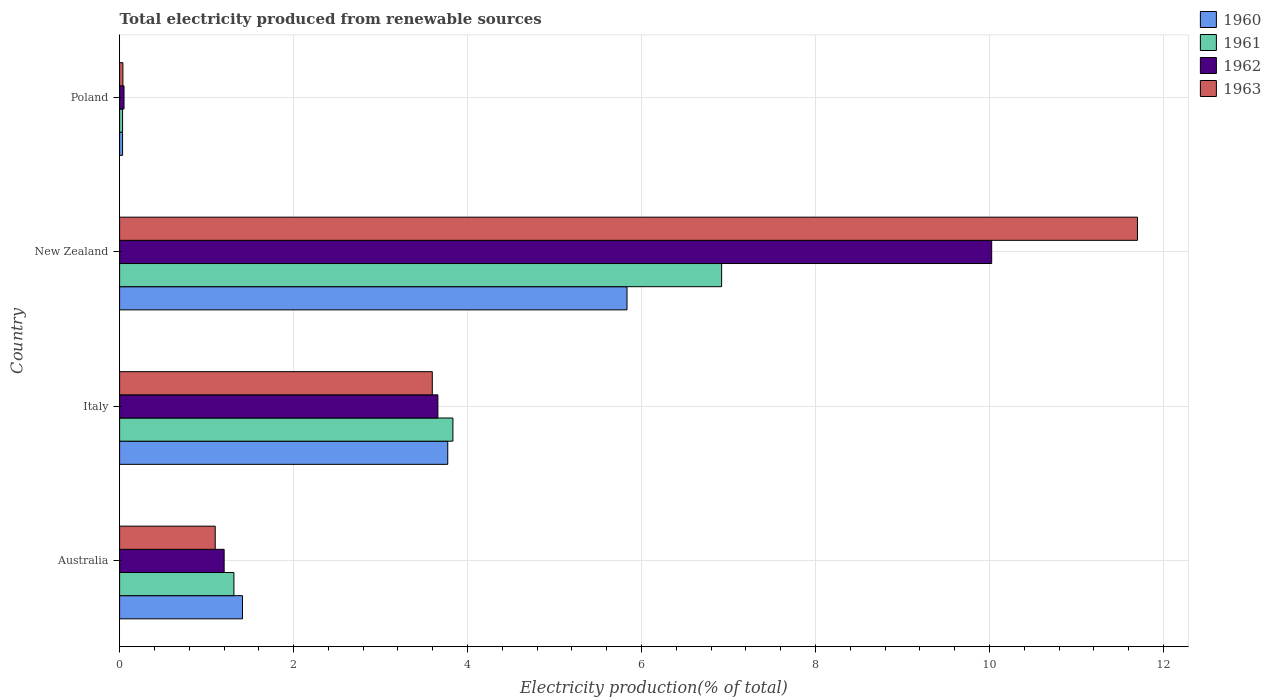How many different coloured bars are there?
Make the answer very short. 4. Are the number of bars on each tick of the Y-axis equal?
Provide a succinct answer. Yes. How many bars are there on the 1st tick from the top?
Your answer should be compact. 4. What is the label of the 2nd group of bars from the top?
Offer a very short reply. New Zealand. What is the total electricity produced in 1963 in Poland?
Make the answer very short. 0.04. Across all countries, what is the maximum total electricity produced in 1960?
Provide a short and direct response. 5.83. Across all countries, what is the minimum total electricity produced in 1963?
Make the answer very short. 0.04. In which country was the total electricity produced in 1963 maximum?
Offer a terse response. New Zealand. What is the total total electricity produced in 1963 in the graph?
Your answer should be compact. 16.43. What is the difference between the total electricity produced in 1963 in Italy and that in New Zealand?
Offer a terse response. -8.11. What is the difference between the total electricity produced in 1963 in Australia and the total electricity produced in 1961 in Italy?
Your response must be concise. -2.73. What is the average total electricity produced in 1963 per country?
Provide a succinct answer. 4.11. What is the difference between the total electricity produced in 1961 and total electricity produced in 1963 in Australia?
Give a very brief answer. 0.21. What is the ratio of the total electricity produced in 1963 in Italy to that in Poland?
Keep it short and to the point. 94.84. What is the difference between the highest and the second highest total electricity produced in 1960?
Provide a short and direct response. 2.06. What is the difference between the highest and the lowest total electricity produced in 1961?
Provide a short and direct response. 6.89. In how many countries, is the total electricity produced in 1961 greater than the average total electricity produced in 1961 taken over all countries?
Ensure brevity in your answer.  2. Is the sum of the total electricity produced in 1963 in Australia and New Zealand greater than the maximum total electricity produced in 1960 across all countries?
Keep it short and to the point. Yes. What does the 4th bar from the top in Australia represents?
Your answer should be very brief. 1960. What does the 1st bar from the bottom in Australia represents?
Ensure brevity in your answer.  1960. Is it the case that in every country, the sum of the total electricity produced in 1960 and total electricity produced in 1963 is greater than the total electricity produced in 1961?
Your answer should be compact. Yes. Are all the bars in the graph horizontal?
Your response must be concise. Yes. Does the graph contain grids?
Offer a terse response. Yes. Where does the legend appear in the graph?
Your response must be concise. Top right. How are the legend labels stacked?
Your answer should be very brief. Vertical. What is the title of the graph?
Keep it short and to the point. Total electricity produced from renewable sources. What is the label or title of the X-axis?
Offer a very short reply. Electricity production(% of total). What is the Electricity production(% of total) in 1960 in Australia?
Ensure brevity in your answer.  1.41. What is the Electricity production(% of total) in 1961 in Australia?
Offer a very short reply. 1.31. What is the Electricity production(% of total) of 1962 in Australia?
Your answer should be very brief. 1.2. What is the Electricity production(% of total) of 1963 in Australia?
Offer a very short reply. 1.1. What is the Electricity production(% of total) in 1960 in Italy?
Provide a short and direct response. 3.77. What is the Electricity production(% of total) in 1961 in Italy?
Ensure brevity in your answer.  3.83. What is the Electricity production(% of total) in 1962 in Italy?
Your answer should be very brief. 3.66. What is the Electricity production(% of total) in 1963 in Italy?
Keep it short and to the point. 3.59. What is the Electricity production(% of total) of 1960 in New Zealand?
Offer a terse response. 5.83. What is the Electricity production(% of total) in 1961 in New Zealand?
Provide a succinct answer. 6.92. What is the Electricity production(% of total) in 1962 in New Zealand?
Your response must be concise. 10.02. What is the Electricity production(% of total) of 1963 in New Zealand?
Provide a succinct answer. 11.7. What is the Electricity production(% of total) of 1960 in Poland?
Keep it short and to the point. 0.03. What is the Electricity production(% of total) in 1961 in Poland?
Your response must be concise. 0.03. What is the Electricity production(% of total) in 1962 in Poland?
Your answer should be compact. 0.05. What is the Electricity production(% of total) in 1963 in Poland?
Your answer should be very brief. 0.04. Across all countries, what is the maximum Electricity production(% of total) of 1960?
Your answer should be compact. 5.83. Across all countries, what is the maximum Electricity production(% of total) of 1961?
Make the answer very short. 6.92. Across all countries, what is the maximum Electricity production(% of total) of 1962?
Keep it short and to the point. 10.02. Across all countries, what is the maximum Electricity production(% of total) of 1963?
Provide a succinct answer. 11.7. Across all countries, what is the minimum Electricity production(% of total) in 1960?
Your answer should be compact. 0.03. Across all countries, what is the minimum Electricity production(% of total) of 1961?
Provide a short and direct response. 0.03. Across all countries, what is the minimum Electricity production(% of total) of 1962?
Your response must be concise. 0.05. Across all countries, what is the minimum Electricity production(% of total) of 1963?
Offer a very short reply. 0.04. What is the total Electricity production(% of total) of 1960 in the graph?
Ensure brevity in your answer.  11.05. What is the total Electricity production(% of total) in 1962 in the graph?
Provide a succinct answer. 14.94. What is the total Electricity production(% of total) in 1963 in the graph?
Your response must be concise. 16.43. What is the difference between the Electricity production(% of total) in 1960 in Australia and that in Italy?
Keep it short and to the point. -2.36. What is the difference between the Electricity production(% of total) in 1961 in Australia and that in Italy?
Your answer should be very brief. -2.52. What is the difference between the Electricity production(% of total) of 1962 in Australia and that in Italy?
Keep it short and to the point. -2.46. What is the difference between the Electricity production(% of total) in 1963 in Australia and that in Italy?
Offer a terse response. -2.5. What is the difference between the Electricity production(% of total) of 1960 in Australia and that in New Zealand?
Offer a very short reply. -4.42. What is the difference between the Electricity production(% of total) in 1961 in Australia and that in New Zealand?
Provide a short and direct response. -5.61. What is the difference between the Electricity production(% of total) of 1962 in Australia and that in New Zealand?
Give a very brief answer. -8.82. What is the difference between the Electricity production(% of total) in 1963 in Australia and that in New Zealand?
Your response must be concise. -10.6. What is the difference between the Electricity production(% of total) of 1960 in Australia and that in Poland?
Ensure brevity in your answer.  1.38. What is the difference between the Electricity production(% of total) of 1961 in Australia and that in Poland?
Provide a short and direct response. 1.28. What is the difference between the Electricity production(% of total) in 1962 in Australia and that in Poland?
Keep it short and to the point. 1.15. What is the difference between the Electricity production(% of total) of 1963 in Australia and that in Poland?
Provide a short and direct response. 1.06. What is the difference between the Electricity production(% of total) of 1960 in Italy and that in New Zealand?
Make the answer very short. -2.06. What is the difference between the Electricity production(% of total) of 1961 in Italy and that in New Zealand?
Offer a terse response. -3.09. What is the difference between the Electricity production(% of total) in 1962 in Italy and that in New Zealand?
Your response must be concise. -6.37. What is the difference between the Electricity production(% of total) of 1963 in Italy and that in New Zealand?
Give a very brief answer. -8.11. What is the difference between the Electricity production(% of total) of 1960 in Italy and that in Poland?
Make the answer very short. 3.74. What is the difference between the Electricity production(% of total) of 1961 in Italy and that in Poland?
Provide a succinct answer. 3.8. What is the difference between the Electricity production(% of total) of 1962 in Italy and that in Poland?
Your answer should be very brief. 3.61. What is the difference between the Electricity production(% of total) in 1963 in Italy and that in Poland?
Your answer should be very brief. 3.56. What is the difference between the Electricity production(% of total) of 1960 in New Zealand and that in Poland?
Keep it short and to the point. 5.8. What is the difference between the Electricity production(% of total) of 1961 in New Zealand and that in Poland?
Make the answer very short. 6.89. What is the difference between the Electricity production(% of total) in 1962 in New Zealand and that in Poland?
Your response must be concise. 9.97. What is the difference between the Electricity production(% of total) of 1963 in New Zealand and that in Poland?
Your response must be concise. 11.66. What is the difference between the Electricity production(% of total) in 1960 in Australia and the Electricity production(% of total) in 1961 in Italy?
Offer a very short reply. -2.42. What is the difference between the Electricity production(% of total) in 1960 in Australia and the Electricity production(% of total) in 1962 in Italy?
Your response must be concise. -2.25. What is the difference between the Electricity production(% of total) of 1960 in Australia and the Electricity production(% of total) of 1963 in Italy?
Provide a short and direct response. -2.18. What is the difference between the Electricity production(% of total) of 1961 in Australia and the Electricity production(% of total) of 1962 in Italy?
Your response must be concise. -2.34. What is the difference between the Electricity production(% of total) in 1961 in Australia and the Electricity production(% of total) in 1963 in Italy?
Your response must be concise. -2.28. What is the difference between the Electricity production(% of total) of 1962 in Australia and the Electricity production(% of total) of 1963 in Italy?
Make the answer very short. -2.39. What is the difference between the Electricity production(% of total) of 1960 in Australia and the Electricity production(% of total) of 1961 in New Zealand?
Give a very brief answer. -5.51. What is the difference between the Electricity production(% of total) in 1960 in Australia and the Electricity production(% of total) in 1962 in New Zealand?
Offer a very short reply. -8.61. What is the difference between the Electricity production(% of total) in 1960 in Australia and the Electricity production(% of total) in 1963 in New Zealand?
Provide a short and direct response. -10.29. What is the difference between the Electricity production(% of total) in 1961 in Australia and the Electricity production(% of total) in 1962 in New Zealand?
Your response must be concise. -8.71. What is the difference between the Electricity production(% of total) in 1961 in Australia and the Electricity production(% of total) in 1963 in New Zealand?
Ensure brevity in your answer.  -10.39. What is the difference between the Electricity production(% of total) in 1962 in Australia and the Electricity production(% of total) in 1963 in New Zealand?
Your response must be concise. -10.5. What is the difference between the Electricity production(% of total) of 1960 in Australia and the Electricity production(% of total) of 1961 in Poland?
Offer a terse response. 1.38. What is the difference between the Electricity production(% of total) in 1960 in Australia and the Electricity production(% of total) in 1962 in Poland?
Provide a succinct answer. 1.36. What is the difference between the Electricity production(% of total) of 1960 in Australia and the Electricity production(% of total) of 1963 in Poland?
Provide a short and direct response. 1.37. What is the difference between the Electricity production(% of total) of 1961 in Australia and the Electricity production(% of total) of 1962 in Poland?
Give a very brief answer. 1.26. What is the difference between the Electricity production(% of total) in 1961 in Australia and the Electricity production(% of total) in 1963 in Poland?
Offer a very short reply. 1.28. What is the difference between the Electricity production(% of total) of 1962 in Australia and the Electricity production(% of total) of 1963 in Poland?
Your answer should be compact. 1.16. What is the difference between the Electricity production(% of total) of 1960 in Italy and the Electricity production(% of total) of 1961 in New Zealand?
Ensure brevity in your answer.  -3.15. What is the difference between the Electricity production(% of total) in 1960 in Italy and the Electricity production(% of total) in 1962 in New Zealand?
Offer a terse response. -6.25. What is the difference between the Electricity production(% of total) of 1960 in Italy and the Electricity production(% of total) of 1963 in New Zealand?
Provide a succinct answer. -7.93. What is the difference between the Electricity production(% of total) in 1961 in Italy and the Electricity production(% of total) in 1962 in New Zealand?
Offer a terse response. -6.19. What is the difference between the Electricity production(% of total) in 1961 in Italy and the Electricity production(% of total) in 1963 in New Zealand?
Offer a very short reply. -7.87. What is the difference between the Electricity production(% of total) in 1962 in Italy and the Electricity production(% of total) in 1963 in New Zealand?
Give a very brief answer. -8.04. What is the difference between the Electricity production(% of total) in 1960 in Italy and the Electricity production(% of total) in 1961 in Poland?
Provide a short and direct response. 3.74. What is the difference between the Electricity production(% of total) of 1960 in Italy and the Electricity production(% of total) of 1962 in Poland?
Offer a terse response. 3.72. What is the difference between the Electricity production(% of total) in 1960 in Italy and the Electricity production(% of total) in 1963 in Poland?
Give a very brief answer. 3.73. What is the difference between the Electricity production(% of total) in 1961 in Italy and the Electricity production(% of total) in 1962 in Poland?
Give a very brief answer. 3.78. What is the difference between the Electricity production(% of total) in 1961 in Italy and the Electricity production(% of total) in 1963 in Poland?
Give a very brief answer. 3.79. What is the difference between the Electricity production(% of total) in 1962 in Italy and the Electricity production(% of total) in 1963 in Poland?
Your response must be concise. 3.62. What is the difference between the Electricity production(% of total) in 1960 in New Zealand and the Electricity production(% of total) in 1961 in Poland?
Provide a short and direct response. 5.8. What is the difference between the Electricity production(% of total) in 1960 in New Zealand and the Electricity production(% of total) in 1962 in Poland?
Offer a terse response. 5.78. What is the difference between the Electricity production(% of total) in 1960 in New Zealand and the Electricity production(% of total) in 1963 in Poland?
Provide a succinct answer. 5.79. What is the difference between the Electricity production(% of total) of 1961 in New Zealand and the Electricity production(% of total) of 1962 in Poland?
Ensure brevity in your answer.  6.87. What is the difference between the Electricity production(% of total) in 1961 in New Zealand and the Electricity production(% of total) in 1963 in Poland?
Your answer should be compact. 6.88. What is the difference between the Electricity production(% of total) in 1962 in New Zealand and the Electricity production(% of total) in 1963 in Poland?
Offer a terse response. 9.99. What is the average Electricity production(% of total) of 1960 per country?
Keep it short and to the point. 2.76. What is the average Electricity production(% of total) in 1961 per country?
Your answer should be compact. 3.02. What is the average Electricity production(% of total) of 1962 per country?
Make the answer very short. 3.73. What is the average Electricity production(% of total) of 1963 per country?
Your answer should be compact. 4.11. What is the difference between the Electricity production(% of total) of 1960 and Electricity production(% of total) of 1961 in Australia?
Ensure brevity in your answer.  0.1. What is the difference between the Electricity production(% of total) of 1960 and Electricity production(% of total) of 1962 in Australia?
Ensure brevity in your answer.  0.21. What is the difference between the Electricity production(% of total) of 1960 and Electricity production(% of total) of 1963 in Australia?
Make the answer very short. 0.31. What is the difference between the Electricity production(% of total) of 1961 and Electricity production(% of total) of 1962 in Australia?
Provide a succinct answer. 0.11. What is the difference between the Electricity production(% of total) in 1961 and Electricity production(% of total) in 1963 in Australia?
Provide a succinct answer. 0.21. What is the difference between the Electricity production(% of total) of 1962 and Electricity production(% of total) of 1963 in Australia?
Your response must be concise. 0.1. What is the difference between the Electricity production(% of total) in 1960 and Electricity production(% of total) in 1961 in Italy?
Offer a terse response. -0.06. What is the difference between the Electricity production(% of total) in 1960 and Electricity production(% of total) in 1962 in Italy?
Offer a very short reply. 0.11. What is the difference between the Electricity production(% of total) in 1960 and Electricity production(% of total) in 1963 in Italy?
Provide a short and direct response. 0.18. What is the difference between the Electricity production(% of total) in 1961 and Electricity production(% of total) in 1962 in Italy?
Provide a short and direct response. 0.17. What is the difference between the Electricity production(% of total) of 1961 and Electricity production(% of total) of 1963 in Italy?
Give a very brief answer. 0.24. What is the difference between the Electricity production(% of total) of 1962 and Electricity production(% of total) of 1963 in Italy?
Your answer should be compact. 0.06. What is the difference between the Electricity production(% of total) of 1960 and Electricity production(% of total) of 1961 in New Zealand?
Keep it short and to the point. -1.09. What is the difference between the Electricity production(% of total) in 1960 and Electricity production(% of total) in 1962 in New Zealand?
Your response must be concise. -4.19. What is the difference between the Electricity production(% of total) of 1960 and Electricity production(% of total) of 1963 in New Zealand?
Your response must be concise. -5.87. What is the difference between the Electricity production(% of total) in 1961 and Electricity production(% of total) in 1962 in New Zealand?
Your answer should be very brief. -3.1. What is the difference between the Electricity production(% of total) in 1961 and Electricity production(% of total) in 1963 in New Zealand?
Make the answer very short. -4.78. What is the difference between the Electricity production(% of total) in 1962 and Electricity production(% of total) in 1963 in New Zealand?
Your response must be concise. -1.68. What is the difference between the Electricity production(% of total) of 1960 and Electricity production(% of total) of 1961 in Poland?
Your answer should be very brief. 0. What is the difference between the Electricity production(% of total) in 1960 and Electricity production(% of total) in 1962 in Poland?
Keep it short and to the point. -0.02. What is the difference between the Electricity production(% of total) of 1960 and Electricity production(% of total) of 1963 in Poland?
Provide a short and direct response. -0. What is the difference between the Electricity production(% of total) in 1961 and Electricity production(% of total) in 1962 in Poland?
Ensure brevity in your answer.  -0.02. What is the difference between the Electricity production(% of total) of 1961 and Electricity production(% of total) of 1963 in Poland?
Offer a terse response. -0. What is the difference between the Electricity production(% of total) of 1962 and Electricity production(% of total) of 1963 in Poland?
Ensure brevity in your answer.  0.01. What is the ratio of the Electricity production(% of total) of 1960 in Australia to that in Italy?
Your answer should be very brief. 0.37. What is the ratio of the Electricity production(% of total) of 1961 in Australia to that in Italy?
Provide a succinct answer. 0.34. What is the ratio of the Electricity production(% of total) in 1962 in Australia to that in Italy?
Your answer should be very brief. 0.33. What is the ratio of the Electricity production(% of total) of 1963 in Australia to that in Italy?
Provide a succinct answer. 0.31. What is the ratio of the Electricity production(% of total) of 1960 in Australia to that in New Zealand?
Your response must be concise. 0.24. What is the ratio of the Electricity production(% of total) of 1961 in Australia to that in New Zealand?
Make the answer very short. 0.19. What is the ratio of the Electricity production(% of total) of 1962 in Australia to that in New Zealand?
Your answer should be compact. 0.12. What is the ratio of the Electricity production(% of total) of 1963 in Australia to that in New Zealand?
Keep it short and to the point. 0.09. What is the ratio of the Electricity production(% of total) in 1960 in Australia to that in Poland?
Your answer should be very brief. 41.37. What is the ratio of the Electricity production(% of total) of 1961 in Australia to that in Poland?
Your answer should be very brief. 38.51. What is the ratio of the Electricity production(% of total) in 1962 in Australia to that in Poland?
Provide a short and direct response. 23.61. What is the ratio of the Electricity production(% of total) of 1963 in Australia to that in Poland?
Your answer should be very brief. 29. What is the ratio of the Electricity production(% of total) in 1960 in Italy to that in New Zealand?
Your answer should be compact. 0.65. What is the ratio of the Electricity production(% of total) in 1961 in Italy to that in New Zealand?
Your answer should be compact. 0.55. What is the ratio of the Electricity production(% of total) of 1962 in Italy to that in New Zealand?
Offer a terse response. 0.36. What is the ratio of the Electricity production(% of total) in 1963 in Italy to that in New Zealand?
Provide a succinct answer. 0.31. What is the ratio of the Electricity production(% of total) in 1960 in Italy to that in Poland?
Ensure brevity in your answer.  110.45. What is the ratio of the Electricity production(% of total) in 1961 in Italy to that in Poland?
Keep it short and to the point. 112.3. What is the ratio of the Electricity production(% of total) of 1962 in Italy to that in Poland?
Your answer should be very brief. 71.88. What is the ratio of the Electricity production(% of total) in 1963 in Italy to that in Poland?
Provide a succinct answer. 94.84. What is the ratio of the Electricity production(% of total) of 1960 in New Zealand to that in Poland?
Make the answer very short. 170.79. What is the ratio of the Electricity production(% of total) in 1961 in New Zealand to that in Poland?
Make the answer very short. 202.83. What is the ratio of the Electricity production(% of total) in 1962 in New Zealand to that in Poland?
Your answer should be compact. 196.95. What is the ratio of the Electricity production(% of total) in 1963 in New Zealand to that in Poland?
Offer a very short reply. 308.73. What is the difference between the highest and the second highest Electricity production(% of total) of 1960?
Ensure brevity in your answer.  2.06. What is the difference between the highest and the second highest Electricity production(% of total) in 1961?
Your answer should be compact. 3.09. What is the difference between the highest and the second highest Electricity production(% of total) of 1962?
Offer a very short reply. 6.37. What is the difference between the highest and the second highest Electricity production(% of total) in 1963?
Offer a terse response. 8.11. What is the difference between the highest and the lowest Electricity production(% of total) of 1960?
Offer a terse response. 5.8. What is the difference between the highest and the lowest Electricity production(% of total) in 1961?
Provide a succinct answer. 6.89. What is the difference between the highest and the lowest Electricity production(% of total) of 1962?
Your answer should be very brief. 9.97. What is the difference between the highest and the lowest Electricity production(% of total) in 1963?
Provide a short and direct response. 11.66. 